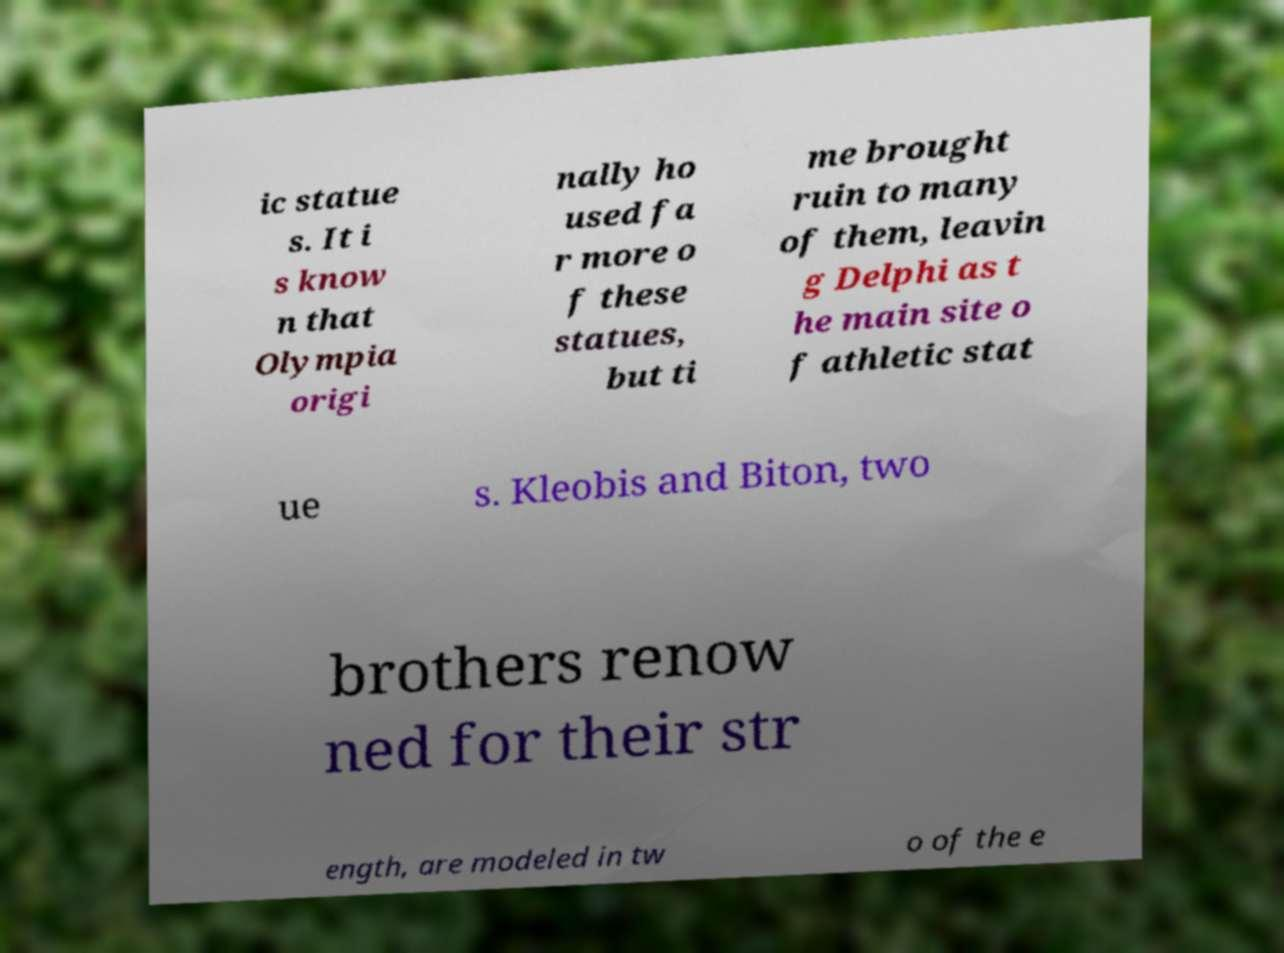Please identify and transcribe the text found in this image. ic statue s. It i s know n that Olympia origi nally ho used fa r more o f these statues, but ti me brought ruin to many of them, leavin g Delphi as t he main site o f athletic stat ue s. Kleobis and Biton, two brothers renow ned for their str ength, are modeled in tw o of the e 